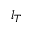<formula> <loc_0><loc_0><loc_500><loc_500>l _ { T }</formula> 